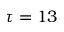<formula> <loc_0><loc_0><loc_500><loc_500>\tau = 1 3</formula> 